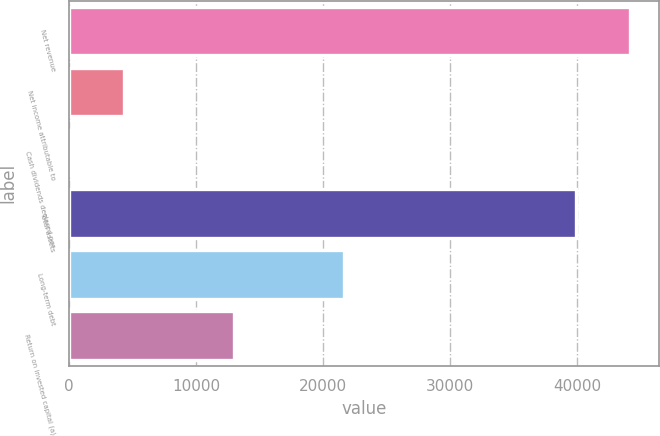Convert chart. <chart><loc_0><loc_0><loc_500><loc_500><bar_chart><fcel>Net revenue<fcel>Net income attributable to<fcel>Cash dividends declared per<fcel>Total assets<fcel>Long-term debt<fcel>Return on invested capital (a)<nl><fcel>44171<fcel>4324.79<fcel>1.77<fcel>39848<fcel>21616.9<fcel>12970.8<nl></chart> 